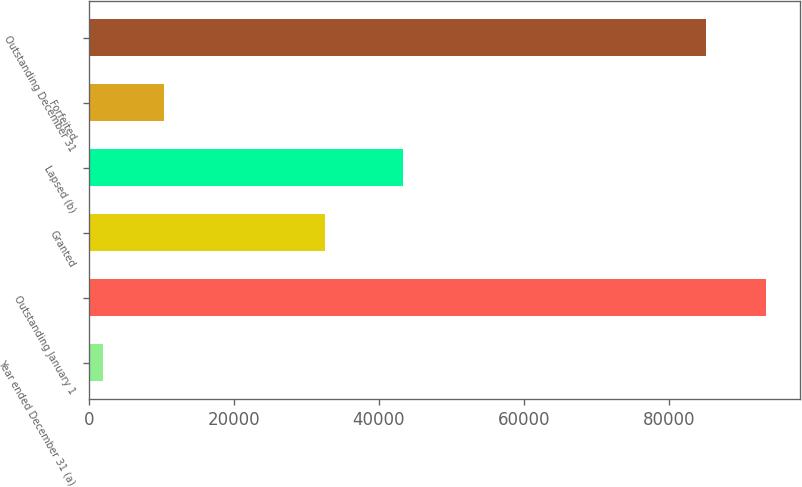Convert chart to OTSL. <chart><loc_0><loc_0><loc_500><loc_500><bar_chart><fcel>Year ended December 31 (a)<fcel>Outstanding January 1<fcel>Granted<fcel>Lapsed (b)<fcel>Forfeited<fcel>Outstanding December 31<nl><fcel>2004<fcel>93451.3<fcel>32514<fcel>43349<fcel>10356.3<fcel>85099<nl></chart> 